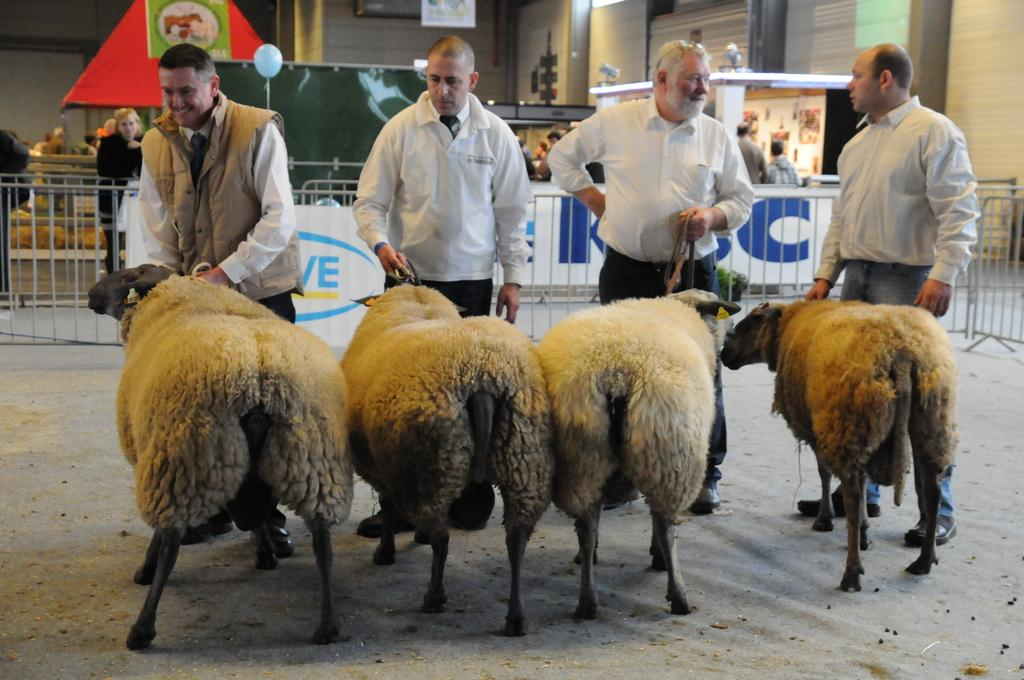What animals are in the foreground of the image? There are four sheep in the foreground of the image. Who is holding the sheep? The sheep are being held by four men. Where are the men standing? The men are standing on the ground. What can be seen in the background of the image? There is railing, persons, stoles, balloons, and a wall in the background of the image. What type of government is being discussed by the sheep in the image? There is no discussion or indication of any government in the image; it features four sheep being held by men. What type of party is being held in the background of the image? There is no party depicted in the image; it features a wall, railing, persons, stoles, and balloons in the background. 